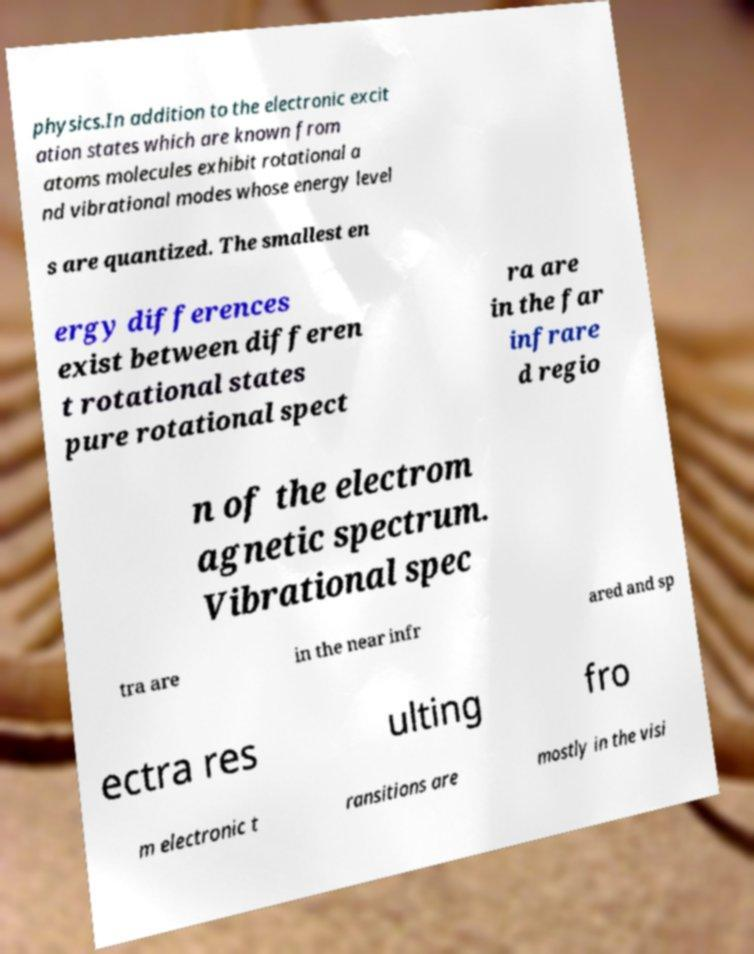Could you extract and type out the text from this image? physics.In addition to the electronic excit ation states which are known from atoms molecules exhibit rotational a nd vibrational modes whose energy level s are quantized. The smallest en ergy differences exist between differen t rotational states pure rotational spect ra are in the far infrare d regio n of the electrom agnetic spectrum. Vibrational spec tra are in the near infr ared and sp ectra res ulting fro m electronic t ransitions are mostly in the visi 